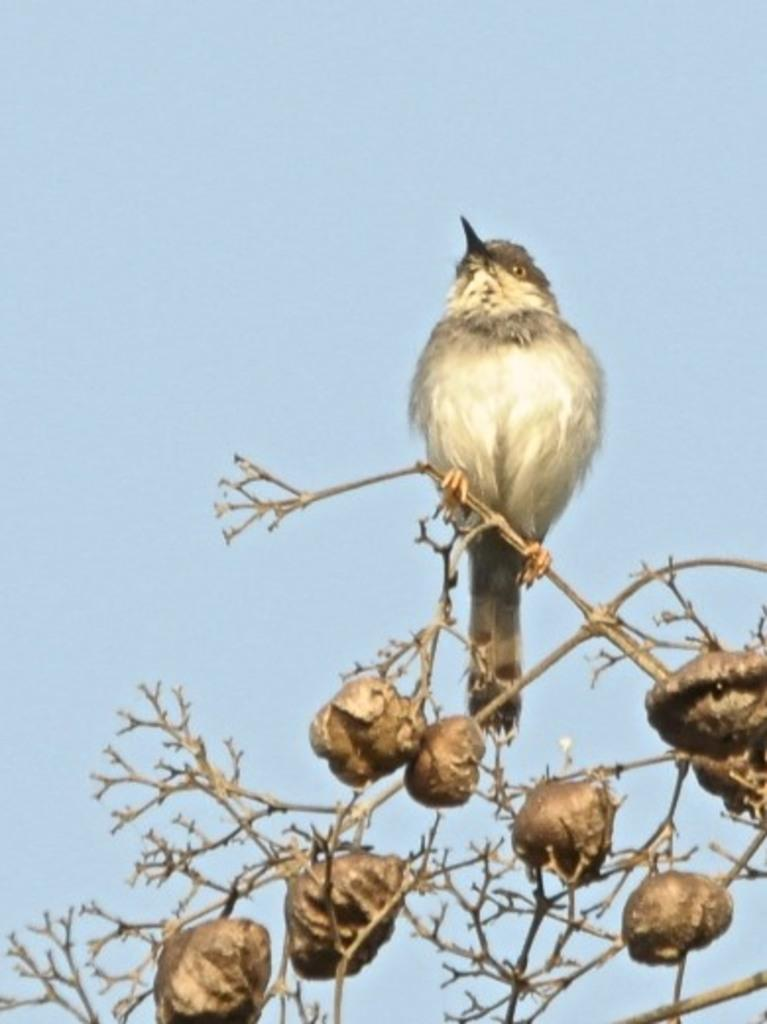What type of animal can be seen in the image? There is a bird in the image. What is the bird standing on? The bird is standing on a plant. What is the condition of the sky in the image? The sky is cloudy in the image. What type of silk is the bird using to weave its nest in the image? There is no nest or silk present in the image; the bird is simply standing on a plant. 